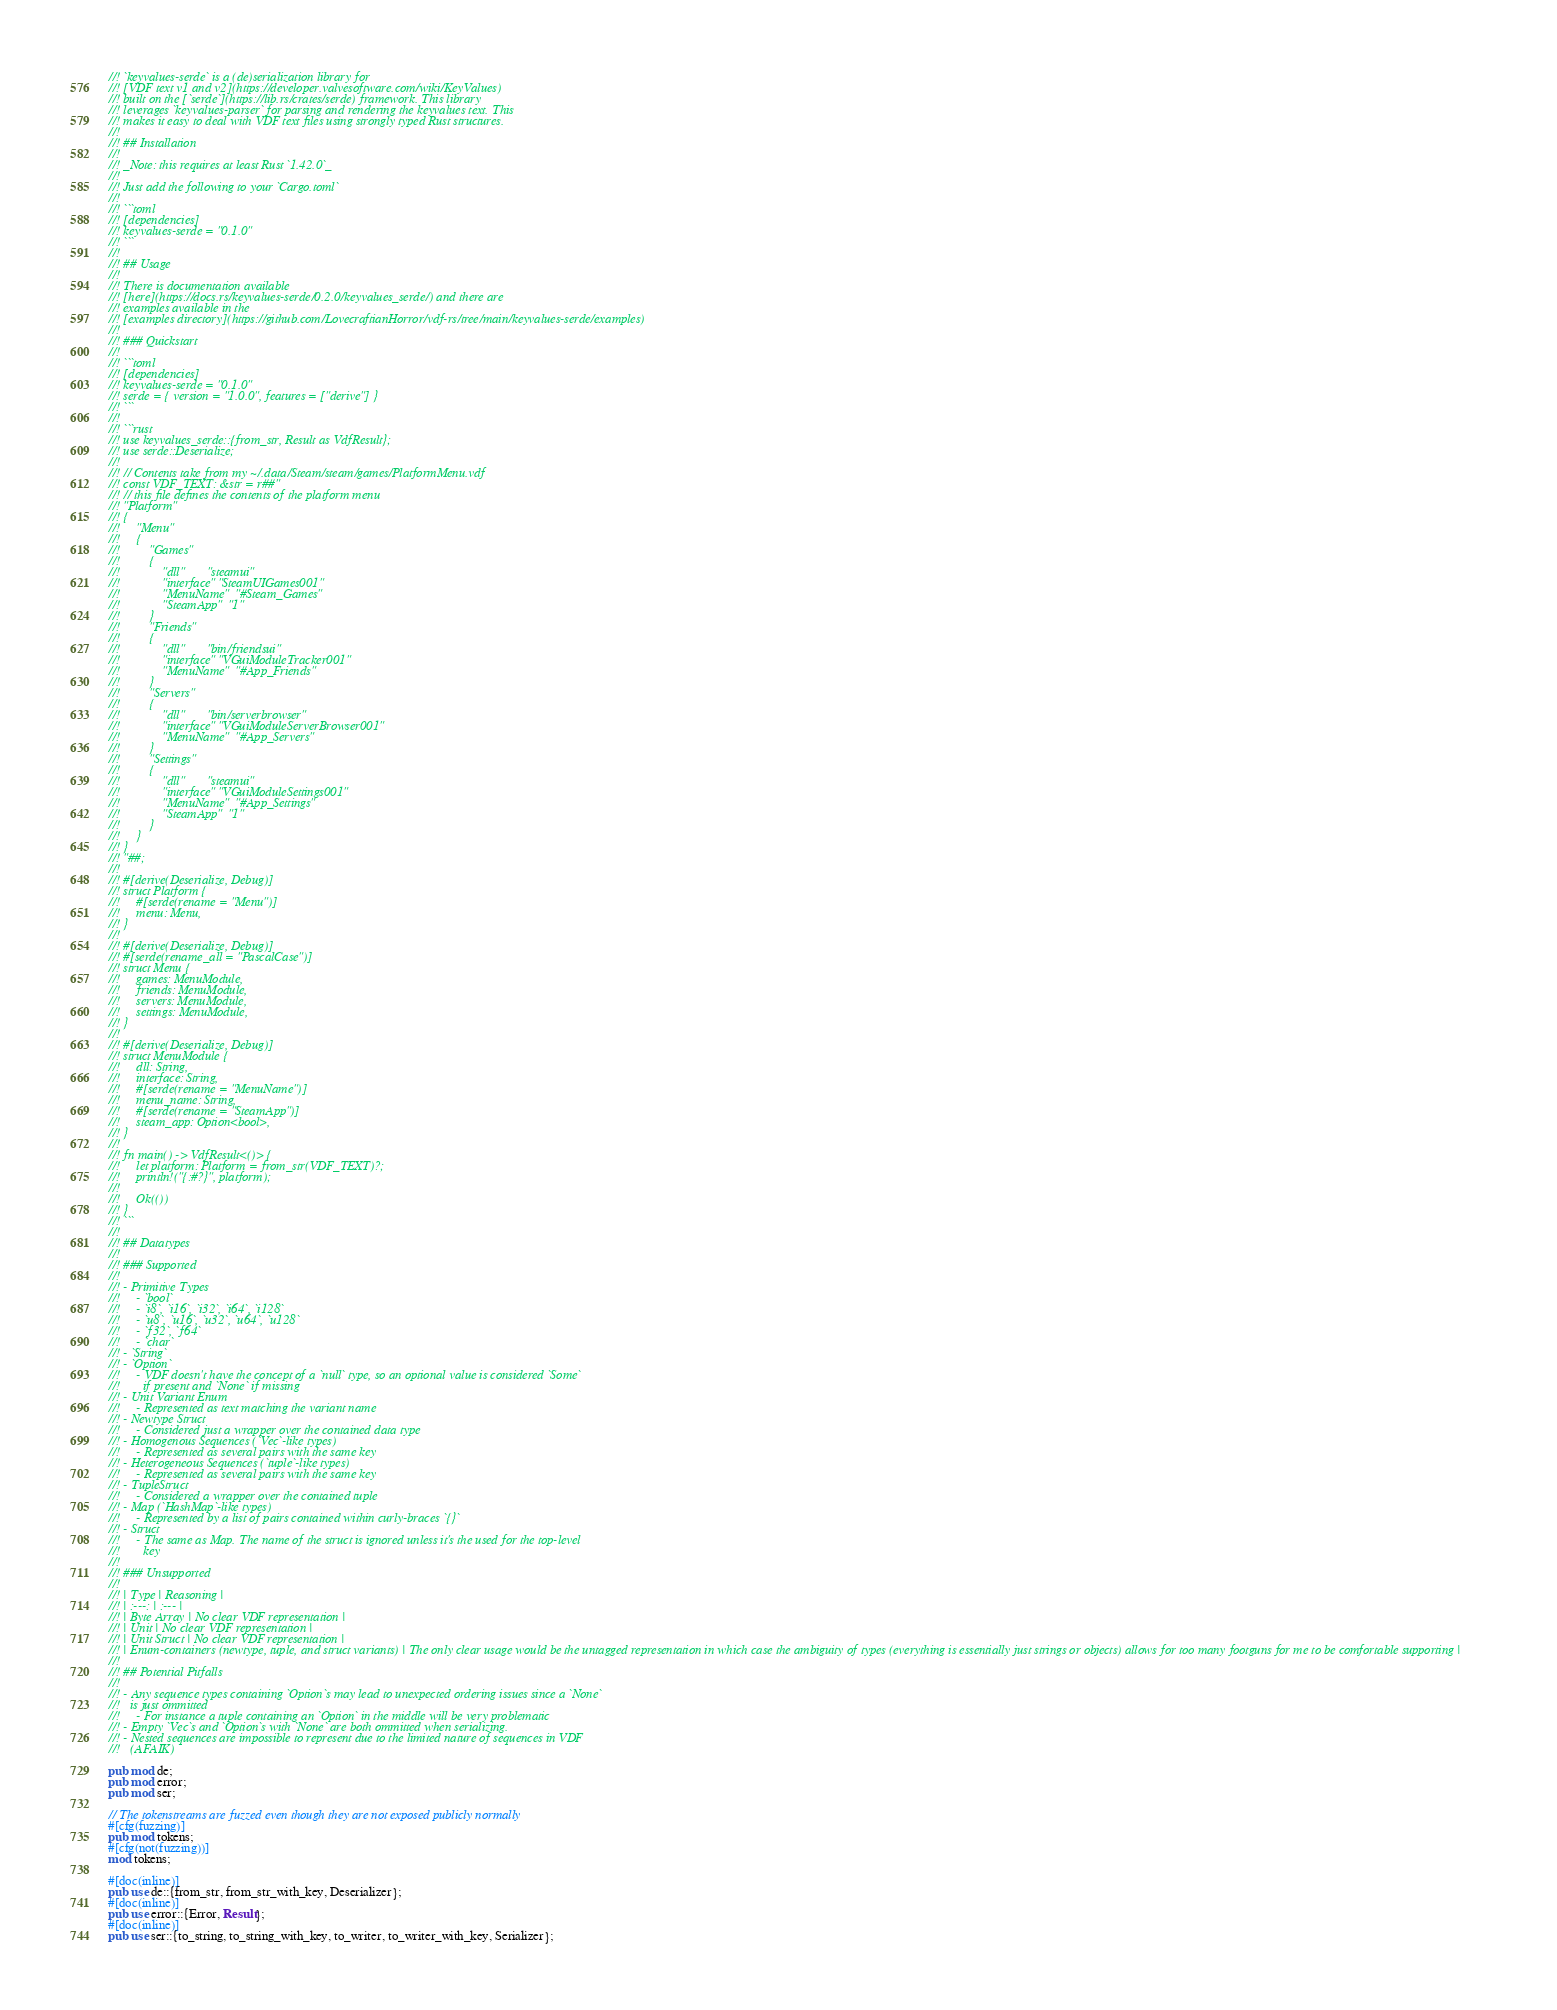<code> <loc_0><loc_0><loc_500><loc_500><_Rust_>//! `keyvalues-serde` is a (de)serialization library for
//! [VDF text v1 and v2](https://developer.valvesoftware.com/wiki/KeyValues)
//! built on the [`serde`](https://lib.rs/crates/serde) framework. This library
//! leverages `keyvalues-parser` for parsing and rendering the keyvalues text. This
//! makes it easy to deal with VDF text files using strongly typed Rust structures.
//!
//! ## Installation
//!
//! _Note: this requires at least Rust `1.42.0`_
//!
//! Just add the following to your `Cargo.toml`
//!
//! ```toml
//! [dependencies]
//! keyvalues-serde = "0.1.0"
//! ```
//!
//! ## Usage
//!
//! There is documentation available
//! [here](https://docs.rs/keyvalues-serde/0.2.0/keyvalues_serde/) and there are
//! examples available in the
//! [examples directory](https://github.com/LovecraftianHorror/vdf-rs/tree/main/keyvalues-serde/examples)
//!
//! ### Quickstart
//!
//! ```toml
//! [dependencies]
//! keyvalues-serde = "0.1.0"
//! serde = { version = "1.0.0", features = ["derive"] }
//! ```
//!
//! ```rust
//! use keyvalues_serde::{from_str, Result as VdfResult};
//! use serde::Deserialize;
//!
//! // Contents take from my ~/.data/Steam/steam/games/PlatformMenu.vdf
//! const VDF_TEXT: &str = r##"
//! // this file defines the contents of the platform menu
//! "Platform"
//! {
//!     "Menu"
//!     {
//!         "Games"
//!         {
//!             "dll"       "steamui"
//!             "interface" "SteamUIGames001"
//!             "MenuName"  "#Steam_Games"
//!             "SteamApp"  "1"
//!         }
//!         "Friends"
//!         {
//!             "dll"       "bin/friendsui"
//!             "interface" "VGuiModuleTracker001"
//!             "MenuName"  "#App_Friends"
//!         }
//!         "Servers"
//!         {
//!             "dll"       "bin/serverbrowser"
//!             "interface" "VGuiModuleServerBrowser001"
//!             "MenuName"  "#App_Servers"
//!         }
//!         "Settings"
//!         {
//!             "dll"       "steamui"
//!             "interface" "VGuiModuleSettings001"
//!             "MenuName"  "#App_Settings"
//!             "SteamApp"  "1"
//!         }
//!     }
//! }
//! "##;
//!
//! #[derive(Deserialize, Debug)]
//! struct Platform {
//!     #[serde(rename = "Menu")]
//!     menu: Menu,
//! }
//!
//! #[derive(Deserialize, Debug)]
//! #[serde(rename_all = "PascalCase")]
//! struct Menu {
//!     games: MenuModule,
//!     friends: MenuModule,
//!     servers: MenuModule,
//!     settings: MenuModule,
//! }
//!
//! #[derive(Deserialize, Debug)]
//! struct MenuModule {
//!     dll: String,
//!     interface: String,
//!     #[serde(rename = "MenuName")]
//!     menu_name: String,
//!     #[serde(rename = "SteamApp")]
//!     steam_app: Option<bool>,
//! }
//!
//! fn main() -> VdfResult<()> {
//!     let platform: Platform = from_str(VDF_TEXT)?;
//!     println!("{:#?}", platform);
//!
//!     Ok(())
//! }
//! ```
//!
//! ## Datatypes
//!
//! ### Supported
//!
//! - Primitive Types
//!     - `bool`
//!     - `i8`, `i16`, `i32`, `i64`, `i128`
//!     - `u8`, `u16`, `u32`, `u64`, `u128`
//!     - `f32`, `f64`
//!     - `char`
//! - `String`
//! - `Option`
//!     - VDF doesn't have the concept of a `null` type, so an optional value is considered `Some`
//!       if present and `None` if missing
//! - Unit Variant Enum
//!     - Represented as text matching the variant name
//! - Newtype Struct
//!     - Considered just a wrapper over the contained data type
//! - Homogenous Sequences (`Vec`-like types)
//!     - Represented as several pairs with the same key
//! - Heterogeneous Sequences (`tuple`-like types)
//!     - Represented as several pairs with the same key
//! - TupleStruct
//!     - Considered a wrapper over the contained tuple
//! - Map (`HashMap`-like types)
//!     - Represented by a list of pairs contained within curly-braces `{}`
//! - Struct
//!     - The same as Map. The name of the struct is ignored unless it's the used for the top-level
//!       key
//!
//! ### Unsupported
//!
//! | Type | Reasoning |
//! | :---: | :--- |
//! | Byte Array | No clear VDF representation |
//! | Unit | No clear VDF representation |
//! | Unit Struct | No clear VDF representation |
//! | Enum-containers (newtype, tuple, and struct variants) | The only clear usage would be the untagged representation in which case the ambiguity of types (everything is essentially just strings or objects) allows for too many footguns for me to be comfortable supporting |
//!
//! ## Potential Pitfalls
//!
//! - Any sequence types containing `Option`s may lead to unexpected ordering issues since a `None`
//!   is just ommitted
//!     - For instance a tuple containing an `Option` in the middle will be very problematic
//! - Empty `Vec`s and `Option`s with `None` are both ommitted when serializing.
//! - Nested sequences are impossible to represent due to the limited nature of sequences in VDF
//!   (AFAIK)

pub mod de;
pub mod error;
pub mod ser;

// The tokenstreams are fuzzed even though they are not exposed publicly normally
#[cfg(fuzzing)]
pub mod tokens;
#[cfg(not(fuzzing))]
mod tokens;

#[doc(inline)]
pub use de::{from_str, from_str_with_key, Deserializer};
#[doc(inline)]
pub use error::{Error, Result};
#[doc(inline)]
pub use ser::{to_string, to_string_with_key, to_writer, to_writer_with_key, Serializer};
</code> 